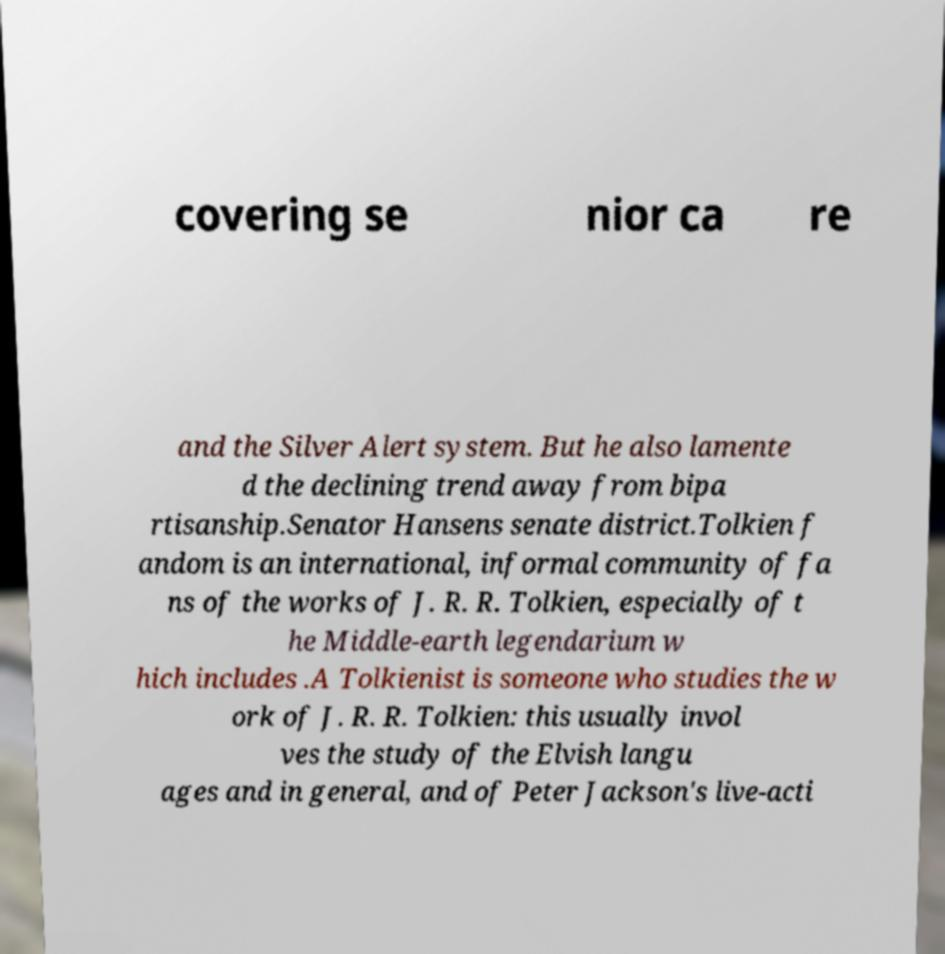Can you read and provide the text displayed in the image?This photo seems to have some interesting text. Can you extract and type it out for me? covering se nior ca re and the Silver Alert system. But he also lamente d the declining trend away from bipa rtisanship.Senator Hansens senate district.Tolkien f andom is an international, informal community of fa ns of the works of J. R. R. Tolkien, especially of t he Middle-earth legendarium w hich includes .A Tolkienist is someone who studies the w ork of J. R. R. Tolkien: this usually invol ves the study of the Elvish langu ages and in general, and of Peter Jackson's live-acti 